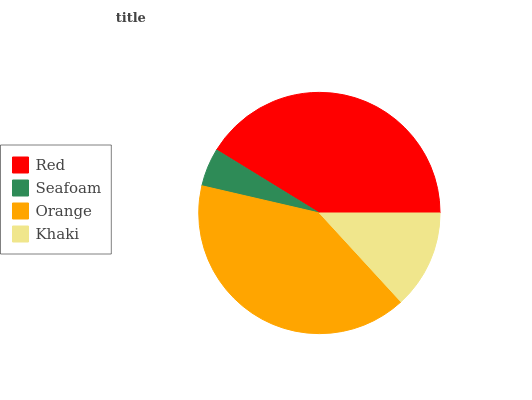Is Seafoam the minimum?
Answer yes or no. Yes. Is Red the maximum?
Answer yes or no. Yes. Is Orange the minimum?
Answer yes or no. No. Is Orange the maximum?
Answer yes or no. No. Is Orange greater than Seafoam?
Answer yes or no. Yes. Is Seafoam less than Orange?
Answer yes or no. Yes. Is Seafoam greater than Orange?
Answer yes or no. No. Is Orange less than Seafoam?
Answer yes or no. No. Is Orange the high median?
Answer yes or no. Yes. Is Khaki the low median?
Answer yes or no. Yes. Is Khaki the high median?
Answer yes or no. No. Is Orange the low median?
Answer yes or no. No. 